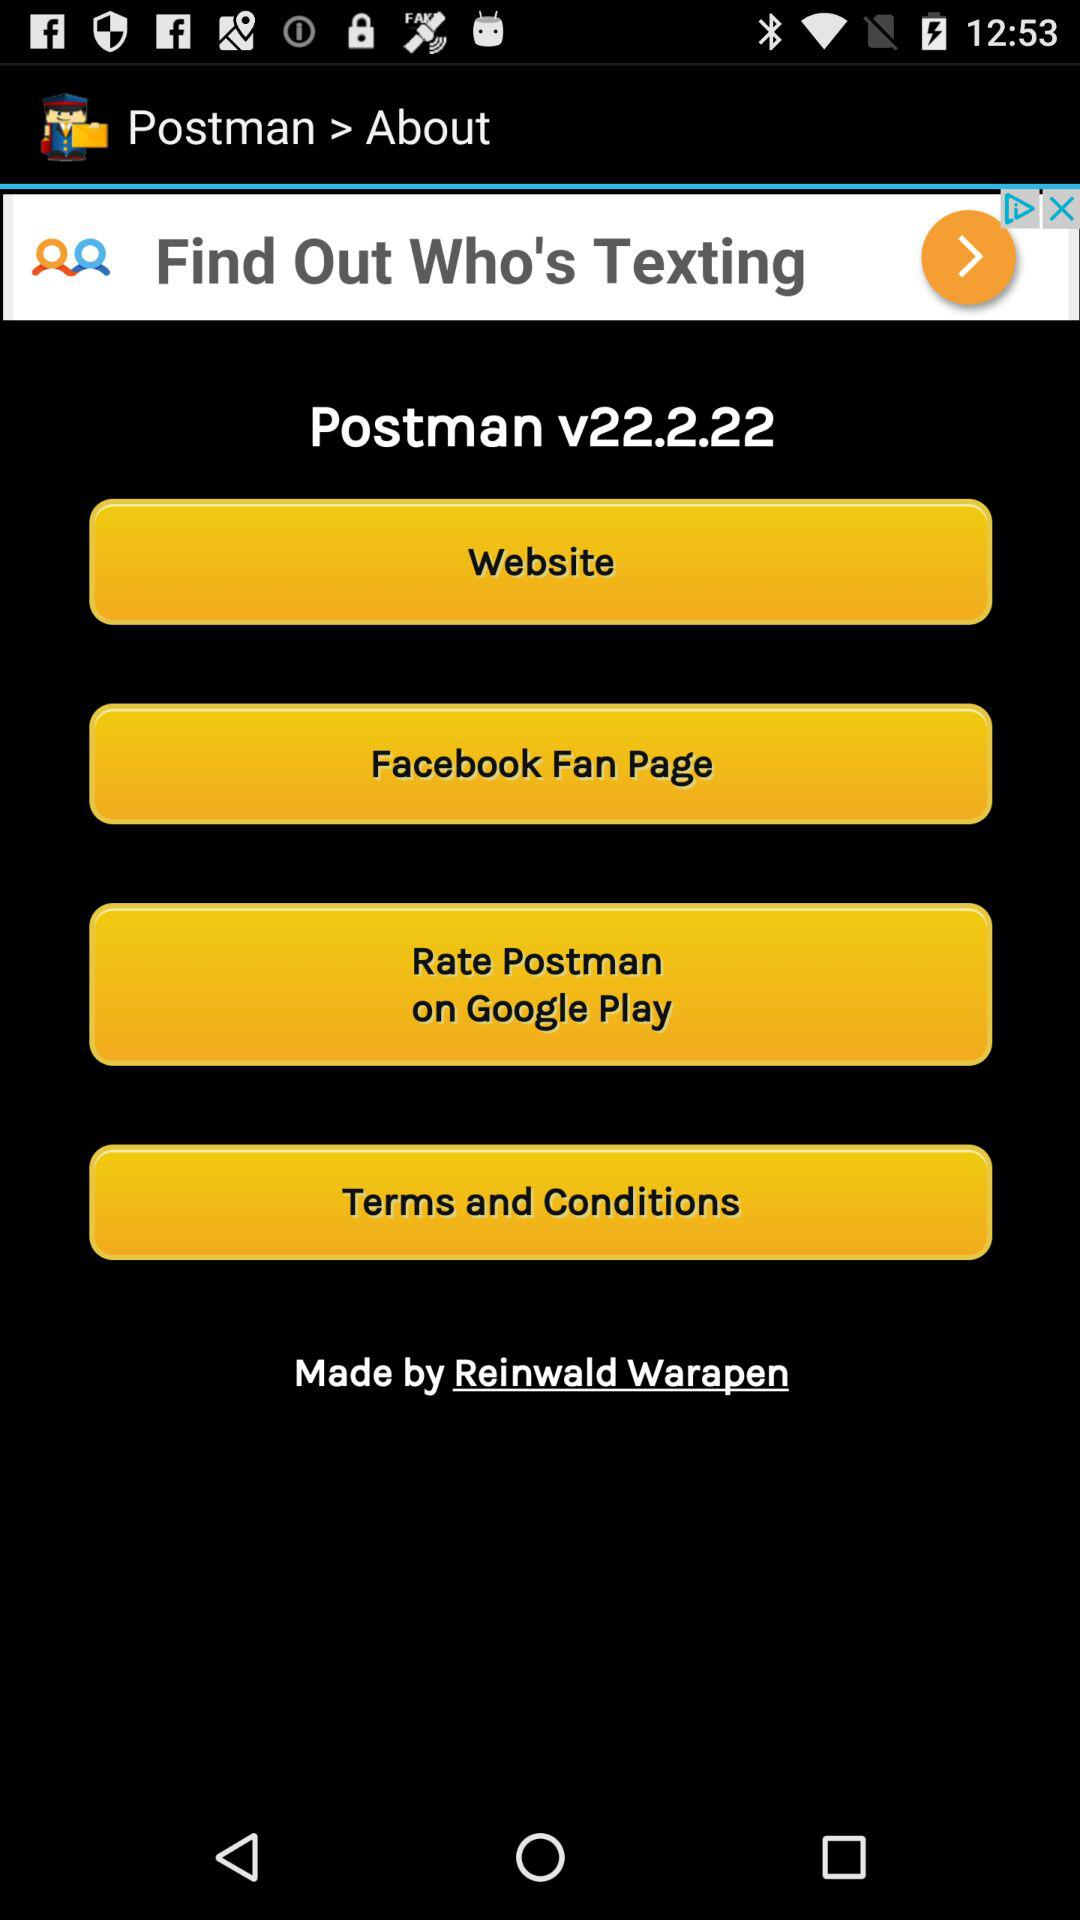Who made the "Postman" application? The "Postman" application is made by Reinwald Warapen. 